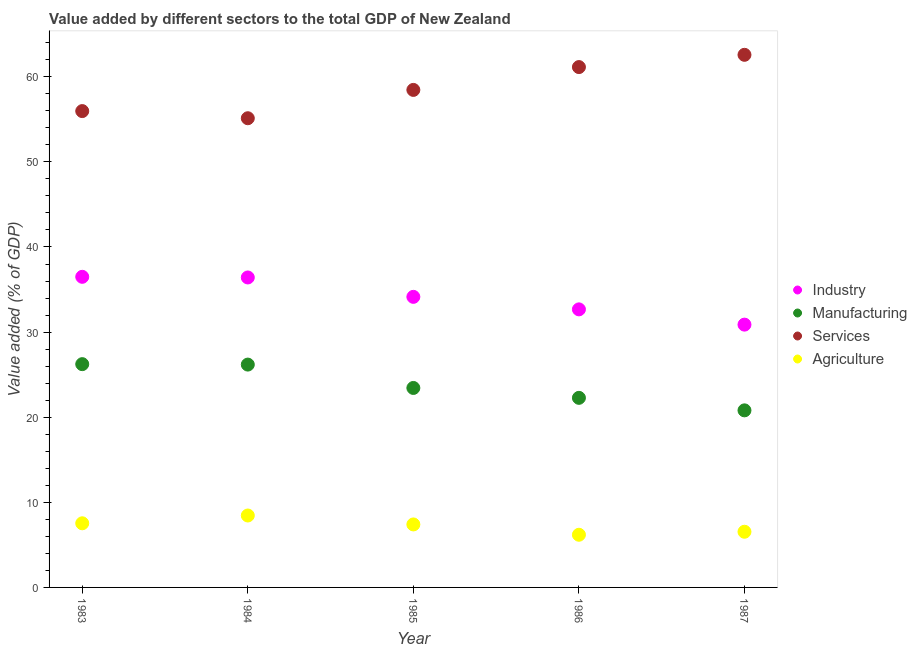How many different coloured dotlines are there?
Your answer should be compact. 4. Is the number of dotlines equal to the number of legend labels?
Offer a terse response. Yes. What is the value added by manufacturing sector in 1987?
Give a very brief answer. 20.81. Across all years, what is the maximum value added by agricultural sector?
Your response must be concise. 8.45. Across all years, what is the minimum value added by services sector?
Offer a very short reply. 55.13. In which year was the value added by services sector maximum?
Ensure brevity in your answer.  1987. What is the total value added by manufacturing sector in the graph?
Ensure brevity in your answer.  118.94. What is the difference between the value added by manufacturing sector in 1983 and that in 1987?
Keep it short and to the point. 5.43. What is the difference between the value added by services sector in 1985 and the value added by agricultural sector in 1984?
Ensure brevity in your answer.  50.01. What is the average value added by agricultural sector per year?
Keep it short and to the point. 7.22. In the year 1983, what is the difference between the value added by services sector and value added by industrial sector?
Ensure brevity in your answer.  19.47. In how many years, is the value added by services sector greater than 38 %?
Offer a very short reply. 5. What is the ratio of the value added by agricultural sector in 1985 to that in 1987?
Offer a terse response. 1.13. What is the difference between the highest and the second highest value added by industrial sector?
Your response must be concise. 0.08. What is the difference between the highest and the lowest value added by services sector?
Make the answer very short. 7.45. In how many years, is the value added by industrial sector greater than the average value added by industrial sector taken over all years?
Make the answer very short. 3. Is it the case that in every year, the sum of the value added by industrial sector and value added by manufacturing sector is greater than the sum of value added by agricultural sector and value added by services sector?
Keep it short and to the point. No. Does the value added by agricultural sector monotonically increase over the years?
Offer a very short reply. No. Is the value added by manufacturing sector strictly greater than the value added by industrial sector over the years?
Your answer should be compact. No. How many years are there in the graph?
Your answer should be very brief. 5. What is the difference between two consecutive major ticks on the Y-axis?
Keep it short and to the point. 10. Does the graph contain any zero values?
Your answer should be compact. No. Does the graph contain grids?
Provide a short and direct response. No. How are the legend labels stacked?
Provide a short and direct response. Vertical. What is the title of the graph?
Ensure brevity in your answer.  Value added by different sectors to the total GDP of New Zealand. Does "Burnt food" appear as one of the legend labels in the graph?
Make the answer very short. No. What is the label or title of the X-axis?
Your answer should be very brief. Year. What is the label or title of the Y-axis?
Provide a short and direct response. Value added (% of GDP). What is the Value added (% of GDP) of Industry in 1983?
Keep it short and to the point. 36.5. What is the Value added (% of GDP) of Manufacturing in 1983?
Your answer should be very brief. 26.23. What is the Value added (% of GDP) in Services in 1983?
Provide a succinct answer. 55.97. What is the Value added (% of GDP) of Agriculture in 1983?
Offer a very short reply. 7.54. What is the Value added (% of GDP) of Industry in 1984?
Make the answer very short. 36.42. What is the Value added (% of GDP) in Manufacturing in 1984?
Provide a short and direct response. 26.18. What is the Value added (% of GDP) of Services in 1984?
Ensure brevity in your answer.  55.13. What is the Value added (% of GDP) in Agriculture in 1984?
Your answer should be very brief. 8.45. What is the Value added (% of GDP) in Industry in 1985?
Your response must be concise. 34.14. What is the Value added (% of GDP) in Manufacturing in 1985?
Your response must be concise. 23.44. What is the Value added (% of GDP) of Services in 1985?
Ensure brevity in your answer.  58.46. What is the Value added (% of GDP) in Agriculture in 1985?
Your response must be concise. 7.4. What is the Value added (% of GDP) of Industry in 1986?
Provide a short and direct response. 32.67. What is the Value added (% of GDP) of Manufacturing in 1986?
Your answer should be very brief. 22.28. What is the Value added (% of GDP) in Services in 1986?
Ensure brevity in your answer.  61.14. What is the Value added (% of GDP) of Agriculture in 1986?
Your answer should be compact. 6.19. What is the Value added (% of GDP) in Industry in 1987?
Provide a succinct answer. 30.88. What is the Value added (% of GDP) in Manufacturing in 1987?
Give a very brief answer. 20.81. What is the Value added (% of GDP) in Services in 1987?
Keep it short and to the point. 62.58. What is the Value added (% of GDP) in Agriculture in 1987?
Offer a terse response. 6.54. Across all years, what is the maximum Value added (% of GDP) of Industry?
Give a very brief answer. 36.5. Across all years, what is the maximum Value added (% of GDP) in Manufacturing?
Give a very brief answer. 26.23. Across all years, what is the maximum Value added (% of GDP) of Services?
Your answer should be very brief. 62.58. Across all years, what is the maximum Value added (% of GDP) of Agriculture?
Your answer should be very brief. 8.45. Across all years, what is the minimum Value added (% of GDP) of Industry?
Your response must be concise. 30.88. Across all years, what is the minimum Value added (% of GDP) in Manufacturing?
Your response must be concise. 20.81. Across all years, what is the minimum Value added (% of GDP) of Services?
Your answer should be very brief. 55.13. Across all years, what is the minimum Value added (% of GDP) of Agriculture?
Your response must be concise. 6.19. What is the total Value added (% of GDP) of Industry in the graph?
Your response must be concise. 170.61. What is the total Value added (% of GDP) of Manufacturing in the graph?
Ensure brevity in your answer.  118.94. What is the total Value added (% of GDP) of Services in the graph?
Offer a terse response. 293.28. What is the total Value added (% of GDP) in Agriculture in the graph?
Keep it short and to the point. 36.12. What is the difference between the Value added (% of GDP) in Industry in 1983 and that in 1984?
Your answer should be compact. 0.08. What is the difference between the Value added (% of GDP) of Manufacturing in 1983 and that in 1984?
Provide a succinct answer. 0.05. What is the difference between the Value added (% of GDP) in Services in 1983 and that in 1984?
Keep it short and to the point. 0.84. What is the difference between the Value added (% of GDP) in Agriculture in 1983 and that in 1984?
Your answer should be compact. -0.92. What is the difference between the Value added (% of GDP) of Industry in 1983 and that in 1985?
Your response must be concise. 2.35. What is the difference between the Value added (% of GDP) of Manufacturing in 1983 and that in 1985?
Provide a succinct answer. 2.8. What is the difference between the Value added (% of GDP) of Services in 1983 and that in 1985?
Your answer should be compact. -2.49. What is the difference between the Value added (% of GDP) of Agriculture in 1983 and that in 1985?
Keep it short and to the point. 0.13. What is the difference between the Value added (% of GDP) of Industry in 1983 and that in 1986?
Give a very brief answer. 3.83. What is the difference between the Value added (% of GDP) in Manufacturing in 1983 and that in 1986?
Your answer should be compact. 3.96. What is the difference between the Value added (% of GDP) of Services in 1983 and that in 1986?
Offer a very short reply. -5.17. What is the difference between the Value added (% of GDP) in Agriculture in 1983 and that in 1986?
Offer a terse response. 1.35. What is the difference between the Value added (% of GDP) of Industry in 1983 and that in 1987?
Your answer should be compact. 5.62. What is the difference between the Value added (% of GDP) of Manufacturing in 1983 and that in 1987?
Offer a terse response. 5.43. What is the difference between the Value added (% of GDP) of Services in 1983 and that in 1987?
Offer a very short reply. -6.61. What is the difference between the Value added (% of GDP) of Industry in 1984 and that in 1985?
Offer a terse response. 2.28. What is the difference between the Value added (% of GDP) in Manufacturing in 1984 and that in 1985?
Provide a succinct answer. 2.75. What is the difference between the Value added (% of GDP) of Services in 1984 and that in 1985?
Your answer should be very brief. -3.33. What is the difference between the Value added (% of GDP) of Agriculture in 1984 and that in 1985?
Offer a very short reply. 1.05. What is the difference between the Value added (% of GDP) of Industry in 1984 and that in 1986?
Provide a succinct answer. 3.75. What is the difference between the Value added (% of GDP) of Manufacturing in 1984 and that in 1986?
Provide a succinct answer. 3.91. What is the difference between the Value added (% of GDP) in Services in 1984 and that in 1986?
Your answer should be very brief. -6.01. What is the difference between the Value added (% of GDP) in Agriculture in 1984 and that in 1986?
Keep it short and to the point. 2.26. What is the difference between the Value added (% of GDP) of Industry in 1984 and that in 1987?
Your answer should be very brief. 5.54. What is the difference between the Value added (% of GDP) of Manufacturing in 1984 and that in 1987?
Keep it short and to the point. 5.38. What is the difference between the Value added (% of GDP) of Services in 1984 and that in 1987?
Provide a succinct answer. -7.45. What is the difference between the Value added (% of GDP) in Agriculture in 1984 and that in 1987?
Offer a terse response. 1.91. What is the difference between the Value added (% of GDP) of Industry in 1985 and that in 1986?
Your answer should be compact. 1.47. What is the difference between the Value added (% of GDP) in Manufacturing in 1985 and that in 1986?
Make the answer very short. 1.16. What is the difference between the Value added (% of GDP) in Services in 1985 and that in 1986?
Your answer should be compact. -2.68. What is the difference between the Value added (% of GDP) in Agriculture in 1985 and that in 1986?
Your answer should be very brief. 1.21. What is the difference between the Value added (% of GDP) in Industry in 1985 and that in 1987?
Your answer should be very brief. 3.26. What is the difference between the Value added (% of GDP) in Manufacturing in 1985 and that in 1987?
Provide a short and direct response. 2.63. What is the difference between the Value added (% of GDP) in Services in 1985 and that in 1987?
Offer a terse response. -4.12. What is the difference between the Value added (% of GDP) in Agriculture in 1985 and that in 1987?
Give a very brief answer. 0.86. What is the difference between the Value added (% of GDP) in Industry in 1986 and that in 1987?
Make the answer very short. 1.79. What is the difference between the Value added (% of GDP) in Manufacturing in 1986 and that in 1987?
Offer a terse response. 1.47. What is the difference between the Value added (% of GDP) in Services in 1986 and that in 1987?
Give a very brief answer. -1.44. What is the difference between the Value added (% of GDP) of Agriculture in 1986 and that in 1987?
Offer a terse response. -0.35. What is the difference between the Value added (% of GDP) of Industry in 1983 and the Value added (% of GDP) of Manufacturing in 1984?
Ensure brevity in your answer.  10.31. What is the difference between the Value added (% of GDP) of Industry in 1983 and the Value added (% of GDP) of Services in 1984?
Provide a succinct answer. -18.63. What is the difference between the Value added (% of GDP) in Industry in 1983 and the Value added (% of GDP) in Agriculture in 1984?
Provide a short and direct response. 28.05. What is the difference between the Value added (% of GDP) in Manufacturing in 1983 and the Value added (% of GDP) in Services in 1984?
Your response must be concise. -28.9. What is the difference between the Value added (% of GDP) in Manufacturing in 1983 and the Value added (% of GDP) in Agriculture in 1984?
Keep it short and to the point. 17.78. What is the difference between the Value added (% of GDP) of Services in 1983 and the Value added (% of GDP) of Agriculture in 1984?
Your answer should be compact. 47.52. What is the difference between the Value added (% of GDP) of Industry in 1983 and the Value added (% of GDP) of Manufacturing in 1985?
Your response must be concise. 13.06. What is the difference between the Value added (% of GDP) of Industry in 1983 and the Value added (% of GDP) of Services in 1985?
Provide a succinct answer. -21.96. What is the difference between the Value added (% of GDP) in Industry in 1983 and the Value added (% of GDP) in Agriculture in 1985?
Your response must be concise. 29.09. What is the difference between the Value added (% of GDP) in Manufacturing in 1983 and the Value added (% of GDP) in Services in 1985?
Your answer should be compact. -32.22. What is the difference between the Value added (% of GDP) of Manufacturing in 1983 and the Value added (% of GDP) of Agriculture in 1985?
Make the answer very short. 18.83. What is the difference between the Value added (% of GDP) of Services in 1983 and the Value added (% of GDP) of Agriculture in 1985?
Your response must be concise. 48.57. What is the difference between the Value added (% of GDP) in Industry in 1983 and the Value added (% of GDP) in Manufacturing in 1986?
Your answer should be compact. 14.22. What is the difference between the Value added (% of GDP) of Industry in 1983 and the Value added (% of GDP) of Services in 1986?
Ensure brevity in your answer.  -24.64. What is the difference between the Value added (% of GDP) of Industry in 1983 and the Value added (% of GDP) of Agriculture in 1986?
Offer a very short reply. 30.31. What is the difference between the Value added (% of GDP) of Manufacturing in 1983 and the Value added (% of GDP) of Services in 1986?
Offer a terse response. -34.91. What is the difference between the Value added (% of GDP) in Manufacturing in 1983 and the Value added (% of GDP) in Agriculture in 1986?
Provide a short and direct response. 20.05. What is the difference between the Value added (% of GDP) in Services in 1983 and the Value added (% of GDP) in Agriculture in 1986?
Give a very brief answer. 49.78. What is the difference between the Value added (% of GDP) in Industry in 1983 and the Value added (% of GDP) in Manufacturing in 1987?
Make the answer very short. 15.69. What is the difference between the Value added (% of GDP) of Industry in 1983 and the Value added (% of GDP) of Services in 1987?
Make the answer very short. -26.08. What is the difference between the Value added (% of GDP) in Industry in 1983 and the Value added (% of GDP) in Agriculture in 1987?
Ensure brevity in your answer.  29.95. What is the difference between the Value added (% of GDP) of Manufacturing in 1983 and the Value added (% of GDP) of Services in 1987?
Keep it short and to the point. -36.35. What is the difference between the Value added (% of GDP) in Manufacturing in 1983 and the Value added (% of GDP) in Agriculture in 1987?
Your answer should be very brief. 19.69. What is the difference between the Value added (% of GDP) of Services in 1983 and the Value added (% of GDP) of Agriculture in 1987?
Keep it short and to the point. 49.43. What is the difference between the Value added (% of GDP) of Industry in 1984 and the Value added (% of GDP) of Manufacturing in 1985?
Offer a terse response. 12.98. What is the difference between the Value added (% of GDP) in Industry in 1984 and the Value added (% of GDP) in Services in 1985?
Ensure brevity in your answer.  -22.04. What is the difference between the Value added (% of GDP) in Industry in 1984 and the Value added (% of GDP) in Agriculture in 1985?
Make the answer very short. 29.02. What is the difference between the Value added (% of GDP) in Manufacturing in 1984 and the Value added (% of GDP) in Services in 1985?
Your answer should be very brief. -32.27. What is the difference between the Value added (% of GDP) in Manufacturing in 1984 and the Value added (% of GDP) in Agriculture in 1985?
Make the answer very short. 18.78. What is the difference between the Value added (% of GDP) of Services in 1984 and the Value added (% of GDP) of Agriculture in 1985?
Provide a short and direct response. 47.73. What is the difference between the Value added (% of GDP) in Industry in 1984 and the Value added (% of GDP) in Manufacturing in 1986?
Your answer should be compact. 14.14. What is the difference between the Value added (% of GDP) in Industry in 1984 and the Value added (% of GDP) in Services in 1986?
Keep it short and to the point. -24.72. What is the difference between the Value added (% of GDP) in Industry in 1984 and the Value added (% of GDP) in Agriculture in 1986?
Ensure brevity in your answer.  30.23. What is the difference between the Value added (% of GDP) in Manufacturing in 1984 and the Value added (% of GDP) in Services in 1986?
Make the answer very short. -34.96. What is the difference between the Value added (% of GDP) in Manufacturing in 1984 and the Value added (% of GDP) in Agriculture in 1986?
Give a very brief answer. 19.99. What is the difference between the Value added (% of GDP) in Services in 1984 and the Value added (% of GDP) in Agriculture in 1986?
Offer a very short reply. 48.94. What is the difference between the Value added (% of GDP) in Industry in 1984 and the Value added (% of GDP) in Manufacturing in 1987?
Your answer should be compact. 15.61. What is the difference between the Value added (% of GDP) of Industry in 1984 and the Value added (% of GDP) of Services in 1987?
Your response must be concise. -26.16. What is the difference between the Value added (% of GDP) of Industry in 1984 and the Value added (% of GDP) of Agriculture in 1987?
Offer a very short reply. 29.88. What is the difference between the Value added (% of GDP) in Manufacturing in 1984 and the Value added (% of GDP) in Services in 1987?
Make the answer very short. -36.4. What is the difference between the Value added (% of GDP) in Manufacturing in 1984 and the Value added (% of GDP) in Agriculture in 1987?
Offer a very short reply. 19.64. What is the difference between the Value added (% of GDP) of Services in 1984 and the Value added (% of GDP) of Agriculture in 1987?
Make the answer very short. 48.59. What is the difference between the Value added (% of GDP) in Industry in 1985 and the Value added (% of GDP) in Manufacturing in 1986?
Provide a short and direct response. 11.87. What is the difference between the Value added (% of GDP) of Industry in 1985 and the Value added (% of GDP) of Services in 1986?
Your response must be concise. -27. What is the difference between the Value added (% of GDP) in Industry in 1985 and the Value added (% of GDP) in Agriculture in 1986?
Make the answer very short. 27.95. What is the difference between the Value added (% of GDP) of Manufacturing in 1985 and the Value added (% of GDP) of Services in 1986?
Keep it short and to the point. -37.7. What is the difference between the Value added (% of GDP) of Manufacturing in 1985 and the Value added (% of GDP) of Agriculture in 1986?
Your answer should be compact. 17.25. What is the difference between the Value added (% of GDP) in Services in 1985 and the Value added (% of GDP) in Agriculture in 1986?
Your response must be concise. 52.27. What is the difference between the Value added (% of GDP) of Industry in 1985 and the Value added (% of GDP) of Manufacturing in 1987?
Offer a terse response. 13.34. What is the difference between the Value added (% of GDP) in Industry in 1985 and the Value added (% of GDP) in Services in 1987?
Keep it short and to the point. -28.44. What is the difference between the Value added (% of GDP) of Industry in 1985 and the Value added (% of GDP) of Agriculture in 1987?
Ensure brevity in your answer.  27.6. What is the difference between the Value added (% of GDP) of Manufacturing in 1985 and the Value added (% of GDP) of Services in 1987?
Keep it short and to the point. -39.14. What is the difference between the Value added (% of GDP) of Manufacturing in 1985 and the Value added (% of GDP) of Agriculture in 1987?
Offer a terse response. 16.9. What is the difference between the Value added (% of GDP) of Services in 1985 and the Value added (% of GDP) of Agriculture in 1987?
Your answer should be very brief. 51.92. What is the difference between the Value added (% of GDP) of Industry in 1986 and the Value added (% of GDP) of Manufacturing in 1987?
Make the answer very short. 11.86. What is the difference between the Value added (% of GDP) of Industry in 1986 and the Value added (% of GDP) of Services in 1987?
Make the answer very short. -29.91. What is the difference between the Value added (% of GDP) in Industry in 1986 and the Value added (% of GDP) in Agriculture in 1987?
Provide a short and direct response. 26.13. What is the difference between the Value added (% of GDP) of Manufacturing in 1986 and the Value added (% of GDP) of Services in 1987?
Your response must be concise. -40.31. What is the difference between the Value added (% of GDP) of Manufacturing in 1986 and the Value added (% of GDP) of Agriculture in 1987?
Provide a succinct answer. 15.73. What is the difference between the Value added (% of GDP) of Services in 1986 and the Value added (% of GDP) of Agriculture in 1987?
Give a very brief answer. 54.6. What is the average Value added (% of GDP) of Industry per year?
Make the answer very short. 34.12. What is the average Value added (% of GDP) in Manufacturing per year?
Your answer should be compact. 23.79. What is the average Value added (% of GDP) in Services per year?
Keep it short and to the point. 58.66. What is the average Value added (% of GDP) of Agriculture per year?
Provide a succinct answer. 7.22. In the year 1983, what is the difference between the Value added (% of GDP) in Industry and Value added (% of GDP) in Manufacturing?
Provide a short and direct response. 10.26. In the year 1983, what is the difference between the Value added (% of GDP) of Industry and Value added (% of GDP) of Services?
Make the answer very short. -19.47. In the year 1983, what is the difference between the Value added (% of GDP) of Industry and Value added (% of GDP) of Agriculture?
Keep it short and to the point. 28.96. In the year 1983, what is the difference between the Value added (% of GDP) in Manufacturing and Value added (% of GDP) in Services?
Offer a very short reply. -29.73. In the year 1983, what is the difference between the Value added (% of GDP) of Manufacturing and Value added (% of GDP) of Agriculture?
Offer a terse response. 18.7. In the year 1983, what is the difference between the Value added (% of GDP) of Services and Value added (% of GDP) of Agriculture?
Keep it short and to the point. 48.43. In the year 1984, what is the difference between the Value added (% of GDP) in Industry and Value added (% of GDP) in Manufacturing?
Your response must be concise. 10.24. In the year 1984, what is the difference between the Value added (% of GDP) in Industry and Value added (% of GDP) in Services?
Provide a succinct answer. -18.71. In the year 1984, what is the difference between the Value added (% of GDP) in Industry and Value added (% of GDP) in Agriculture?
Give a very brief answer. 27.97. In the year 1984, what is the difference between the Value added (% of GDP) in Manufacturing and Value added (% of GDP) in Services?
Ensure brevity in your answer.  -28.95. In the year 1984, what is the difference between the Value added (% of GDP) of Manufacturing and Value added (% of GDP) of Agriculture?
Offer a terse response. 17.73. In the year 1984, what is the difference between the Value added (% of GDP) in Services and Value added (% of GDP) in Agriculture?
Your answer should be compact. 46.68. In the year 1985, what is the difference between the Value added (% of GDP) in Industry and Value added (% of GDP) in Manufacturing?
Offer a terse response. 10.7. In the year 1985, what is the difference between the Value added (% of GDP) of Industry and Value added (% of GDP) of Services?
Provide a succinct answer. -24.32. In the year 1985, what is the difference between the Value added (% of GDP) of Industry and Value added (% of GDP) of Agriculture?
Provide a short and direct response. 26.74. In the year 1985, what is the difference between the Value added (% of GDP) in Manufacturing and Value added (% of GDP) in Services?
Provide a short and direct response. -35.02. In the year 1985, what is the difference between the Value added (% of GDP) of Manufacturing and Value added (% of GDP) of Agriculture?
Your answer should be compact. 16.04. In the year 1985, what is the difference between the Value added (% of GDP) of Services and Value added (% of GDP) of Agriculture?
Provide a short and direct response. 51.06. In the year 1986, what is the difference between the Value added (% of GDP) of Industry and Value added (% of GDP) of Manufacturing?
Provide a short and direct response. 10.4. In the year 1986, what is the difference between the Value added (% of GDP) of Industry and Value added (% of GDP) of Services?
Make the answer very short. -28.47. In the year 1986, what is the difference between the Value added (% of GDP) of Industry and Value added (% of GDP) of Agriculture?
Your answer should be very brief. 26.48. In the year 1986, what is the difference between the Value added (% of GDP) in Manufacturing and Value added (% of GDP) in Services?
Your response must be concise. -38.87. In the year 1986, what is the difference between the Value added (% of GDP) in Manufacturing and Value added (% of GDP) in Agriculture?
Your answer should be compact. 16.09. In the year 1986, what is the difference between the Value added (% of GDP) in Services and Value added (% of GDP) in Agriculture?
Provide a succinct answer. 54.95. In the year 1987, what is the difference between the Value added (% of GDP) in Industry and Value added (% of GDP) in Manufacturing?
Offer a terse response. 10.07. In the year 1987, what is the difference between the Value added (% of GDP) of Industry and Value added (% of GDP) of Services?
Offer a very short reply. -31.7. In the year 1987, what is the difference between the Value added (% of GDP) in Industry and Value added (% of GDP) in Agriculture?
Make the answer very short. 24.34. In the year 1987, what is the difference between the Value added (% of GDP) of Manufacturing and Value added (% of GDP) of Services?
Make the answer very short. -41.77. In the year 1987, what is the difference between the Value added (% of GDP) of Manufacturing and Value added (% of GDP) of Agriculture?
Your answer should be very brief. 14.26. In the year 1987, what is the difference between the Value added (% of GDP) of Services and Value added (% of GDP) of Agriculture?
Your answer should be very brief. 56.04. What is the ratio of the Value added (% of GDP) in Industry in 1983 to that in 1984?
Offer a terse response. 1. What is the ratio of the Value added (% of GDP) in Services in 1983 to that in 1984?
Offer a terse response. 1.02. What is the ratio of the Value added (% of GDP) of Agriculture in 1983 to that in 1984?
Your answer should be compact. 0.89. What is the ratio of the Value added (% of GDP) of Industry in 1983 to that in 1985?
Offer a very short reply. 1.07. What is the ratio of the Value added (% of GDP) of Manufacturing in 1983 to that in 1985?
Keep it short and to the point. 1.12. What is the ratio of the Value added (% of GDP) in Services in 1983 to that in 1985?
Offer a terse response. 0.96. What is the ratio of the Value added (% of GDP) of Agriculture in 1983 to that in 1985?
Ensure brevity in your answer.  1.02. What is the ratio of the Value added (% of GDP) in Industry in 1983 to that in 1986?
Offer a terse response. 1.12. What is the ratio of the Value added (% of GDP) in Manufacturing in 1983 to that in 1986?
Your response must be concise. 1.18. What is the ratio of the Value added (% of GDP) of Services in 1983 to that in 1986?
Keep it short and to the point. 0.92. What is the ratio of the Value added (% of GDP) of Agriculture in 1983 to that in 1986?
Your answer should be compact. 1.22. What is the ratio of the Value added (% of GDP) in Industry in 1983 to that in 1987?
Make the answer very short. 1.18. What is the ratio of the Value added (% of GDP) in Manufacturing in 1983 to that in 1987?
Give a very brief answer. 1.26. What is the ratio of the Value added (% of GDP) of Services in 1983 to that in 1987?
Your answer should be compact. 0.89. What is the ratio of the Value added (% of GDP) in Agriculture in 1983 to that in 1987?
Offer a terse response. 1.15. What is the ratio of the Value added (% of GDP) in Industry in 1984 to that in 1985?
Give a very brief answer. 1.07. What is the ratio of the Value added (% of GDP) of Manufacturing in 1984 to that in 1985?
Make the answer very short. 1.12. What is the ratio of the Value added (% of GDP) of Services in 1984 to that in 1985?
Your answer should be very brief. 0.94. What is the ratio of the Value added (% of GDP) in Agriculture in 1984 to that in 1985?
Give a very brief answer. 1.14. What is the ratio of the Value added (% of GDP) in Industry in 1984 to that in 1986?
Make the answer very short. 1.11. What is the ratio of the Value added (% of GDP) of Manufacturing in 1984 to that in 1986?
Provide a short and direct response. 1.18. What is the ratio of the Value added (% of GDP) in Services in 1984 to that in 1986?
Offer a very short reply. 0.9. What is the ratio of the Value added (% of GDP) in Agriculture in 1984 to that in 1986?
Keep it short and to the point. 1.37. What is the ratio of the Value added (% of GDP) in Industry in 1984 to that in 1987?
Make the answer very short. 1.18. What is the ratio of the Value added (% of GDP) in Manufacturing in 1984 to that in 1987?
Give a very brief answer. 1.26. What is the ratio of the Value added (% of GDP) of Services in 1984 to that in 1987?
Provide a succinct answer. 0.88. What is the ratio of the Value added (% of GDP) of Agriculture in 1984 to that in 1987?
Ensure brevity in your answer.  1.29. What is the ratio of the Value added (% of GDP) in Industry in 1985 to that in 1986?
Keep it short and to the point. 1.04. What is the ratio of the Value added (% of GDP) of Manufacturing in 1985 to that in 1986?
Give a very brief answer. 1.05. What is the ratio of the Value added (% of GDP) of Services in 1985 to that in 1986?
Keep it short and to the point. 0.96. What is the ratio of the Value added (% of GDP) of Agriculture in 1985 to that in 1986?
Your response must be concise. 1.2. What is the ratio of the Value added (% of GDP) of Industry in 1985 to that in 1987?
Offer a terse response. 1.11. What is the ratio of the Value added (% of GDP) of Manufacturing in 1985 to that in 1987?
Your answer should be compact. 1.13. What is the ratio of the Value added (% of GDP) of Services in 1985 to that in 1987?
Provide a short and direct response. 0.93. What is the ratio of the Value added (% of GDP) in Agriculture in 1985 to that in 1987?
Your answer should be very brief. 1.13. What is the ratio of the Value added (% of GDP) in Industry in 1986 to that in 1987?
Your response must be concise. 1.06. What is the ratio of the Value added (% of GDP) in Manufacturing in 1986 to that in 1987?
Make the answer very short. 1.07. What is the ratio of the Value added (% of GDP) in Agriculture in 1986 to that in 1987?
Keep it short and to the point. 0.95. What is the difference between the highest and the second highest Value added (% of GDP) of Industry?
Make the answer very short. 0.08. What is the difference between the highest and the second highest Value added (% of GDP) of Manufacturing?
Make the answer very short. 0.05. What is the difference between the highest and the second highest Value added (% of GDP) of Services?
Your answer should be compact. 1.44. What is the difference between the highest and the second highest Value added (% of GDP) in Agriculture?
Your answer should be compact. 0.92. What is the difference between the highest and the lowest Value added (% of GDP) in Industry?
Keep it short and to the point. 5.62. What is the difference between the highest and the lowest Value added (% of GDP) of Manufacturing?
Give a very brief answer. 5.43. What is the difference between the highest and the lowest Value added (% of GDP) of Services?
Make the answer very short. 7.45. What is the difference between the highest and the lowest Value added (% of GDP) in Agriculture?
Make the answer very short. 2.26. 